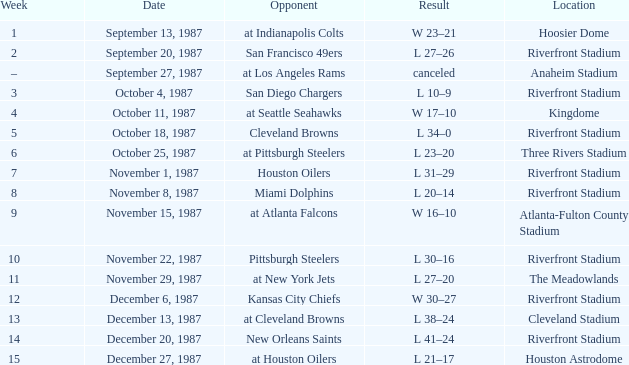What was the result of the game at the Riverfront Stadium after week 8? L 20–14. Give me the full table as a dictionary. {'header': ['Week', 'Date', 'Opponent', 'Result', 'Location'], 'rows': [['1', 'September 13, 1987', 'at Indianapolis Colts', 'W 23–21', 'Hoosier Dome'], ['2', 'September 20, 1987', 'San Francisco 49ers', 'L 27–26', 'Riverfront Stadium'], ['–', 'September 27, 1987', 'at Los Angeles Rams', 'canceled', 'Anaheim Stadium'], ['3', 'October 4, 1987', 'San Diego Chargers', 'L 10–9', 'Riverfront Stadium'], ['4', 'October 11, 1987', 'at Seattle Seahawks', 'W 17–10', 'Kingdome'], ['5', 'October 18, 1987', 'Cleveland Browns', 'L 34–0', 'Riverfront Stadium'], ['6', 'October 25, 1987', 'at Pittsburgh Steelers', 'L 23–20', 'Three Rivers Stadium'], ['7', 'November 1, 1987', 'Houston Oilers', 'L 31–29', 'Riverfront Stadium'], ['8', 'November 8, 1987', 'Miami Dolphins', 'L 20–14', 'Riverfront Stadium'], ['9', 'November 15, 1987', 'at Atlanta Falcons', 'W 16–10', 'Atlanta-Fulton County Stadium'], ['10', 'November 22, 1987', 'Pittsburgh Steelers', 'L 30–16', 'Riverfront Stadium'], ['11', 'November 29, 1987', 'at New York Jets', 'L 27–20', 'The Meadowlands'], ['12', 'December 6, 1987', 'Kansas City Chiefs', 'W 30–27', 'Riverfront Stadium'], ['13', 'December 13, 1987', 'at Cleveland Browns', 'L 38–24', 'Cleveland Stadium'], ['14', 'December 20, 1987', 'New Orleans Saints', 'L 41–24', 'Riverfront Stadium'], ['15', 'December 27, 1987', 'at Houston Oilers', 'L 21–17', 'Houston Astrodome']]} 